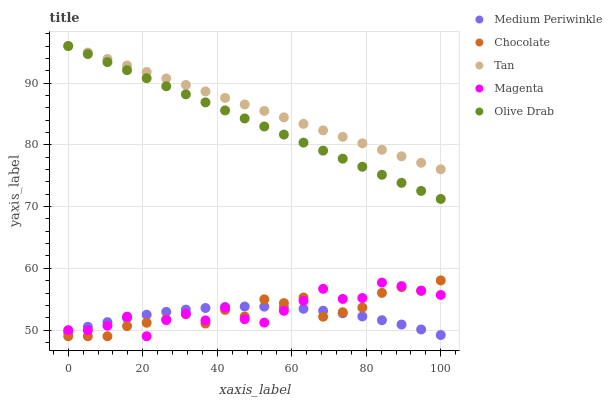Does Medium Periwinkle have the minimum area under the curve?
Answer yes or no. Yes. Does Tan have the maximum area under the curve?
Answer yes or no. Yes. Does Magenta have the minimum area under the curve?
Answer yes or no. No. Does Magenta have the maximum area under the curve?
Answer yes or no. No. Is Olive Drab the smoothest?
Answer yes or no. Yes. Is Magenta the roughest?
Answer yes or no. Yes. Is Medium Periwinkle the smoothest?
Answer yes or no. No. Is Medium Periwinkle the roughest?
Answer yes or no. No. Does Magenta have the lowest value?
Answer yes or no. Yes. Does Medium Periwinkle have the lowest value?
Answer yes or no. No. Does Olive Drab have the highest value?
Answer yes or no. Yes. Does Magenta have the highest value?
Answer yes or no. No. Is Chocolate less than Tan?
Answer yes or no. Yes. Is Olive Drab greater than Magenta?
Answer yes or no. Yes. Does Chocolate intersect Magenta?
Answer yes or no. Yes. Is Chocolate less than Magenta?
Answer yes or no. No. Is Chocolate greater than Magenta?
Answer yes or no. No. Does Chocolate intersect Tan?
Answer yes or no. No. 